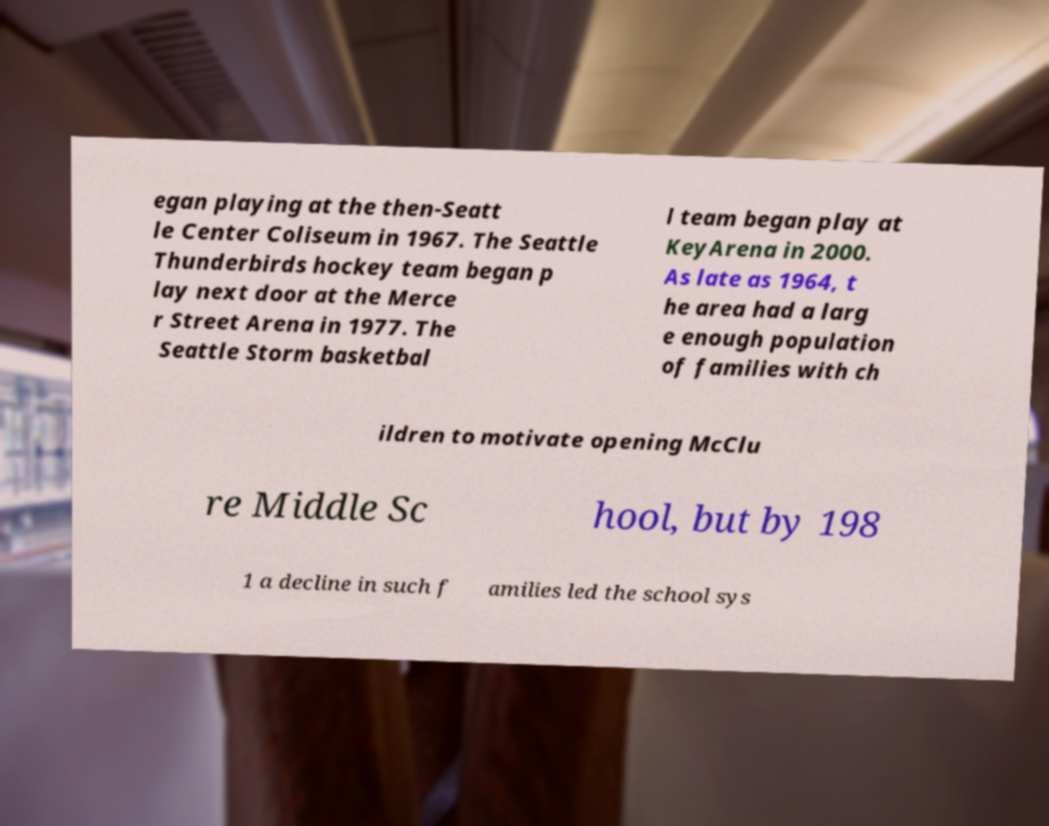Can you read and provide the text displayed in the image?This photo seems to have some interesting text. Can you extract and type it out for me? egan playing at the then-Seatt le Center Coliseum in 1967. The Seattle Thunderbirds hockey team began p lay next door at the Merce r Street Arena in 1977. The Seattle Storm basketbal l team began play at KeyArena in 2000. As late as 1964, t he area had a larg e enough population of families with ch ildren to motivate opening McClu re Middle Sc hool, but by 198 1 a decline in such f amilies led the school sys 